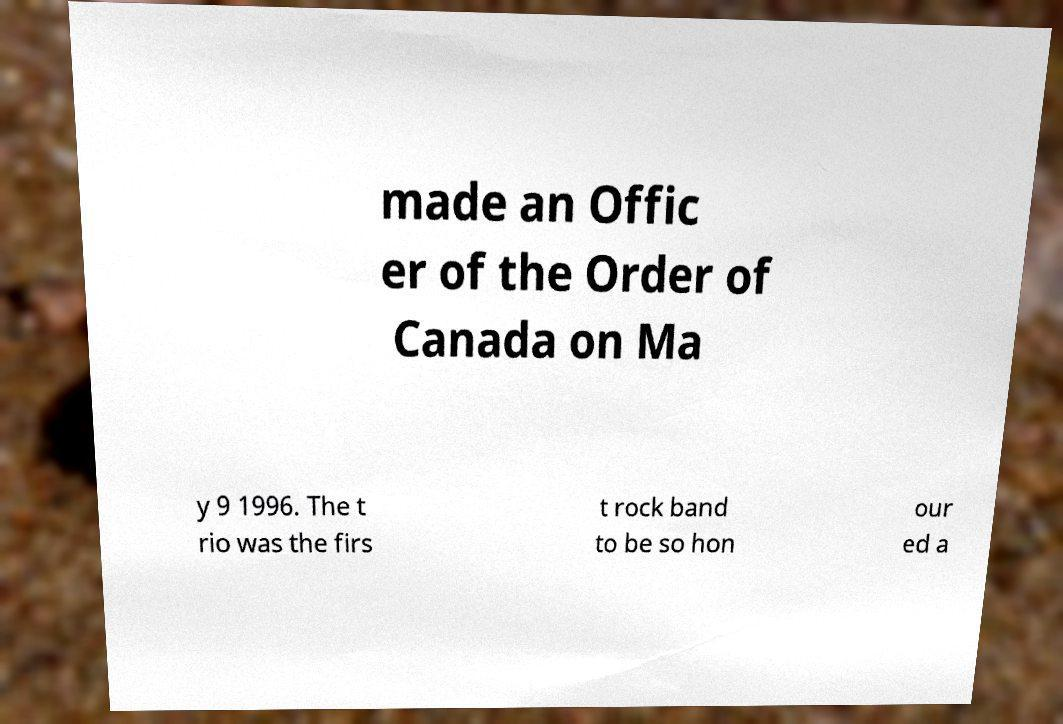Please read and relay the text visible in this image. What does it say? made an Offic er of the Order of Canada on Ma y 9 1996. The t rio was the firs t rock band to be so hon our ed a 